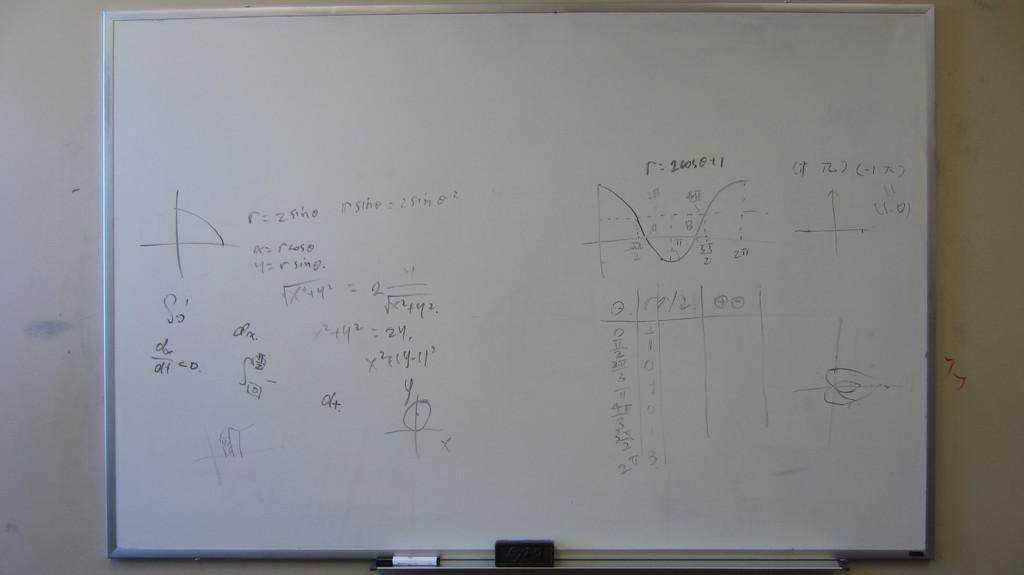<image>
Create a compact narrative representing the image presented. A whiteboard with mathematical graphs and equation such as "r = 2 sin θ". 